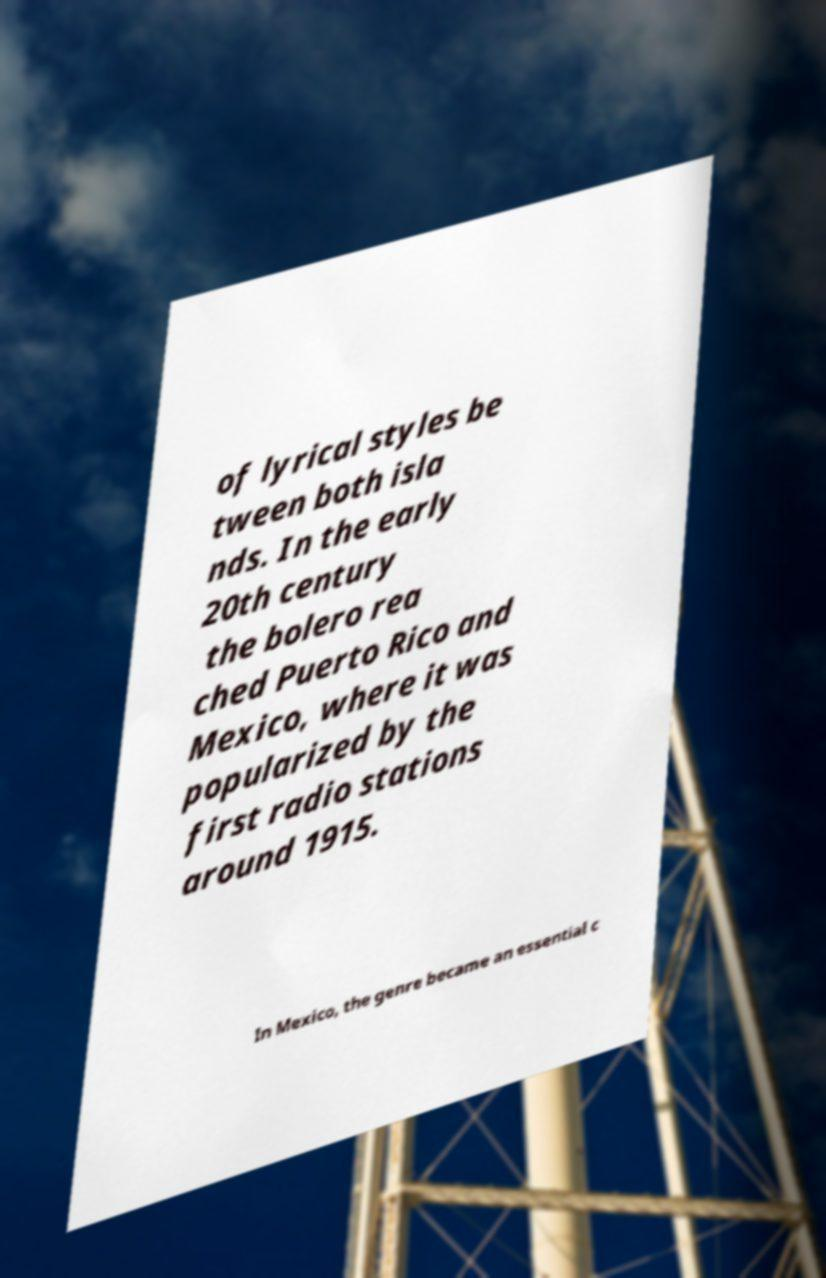For documentation purposes, I need the text within this image transcribed. Could you provide that? of lyrical styles be tween both isla nds. In the early 20th century the bolero rea ched Puerto Rico and Mexico, where it was popularized by the first radio stations around 1915. In Mexico, the genre became an essential c 